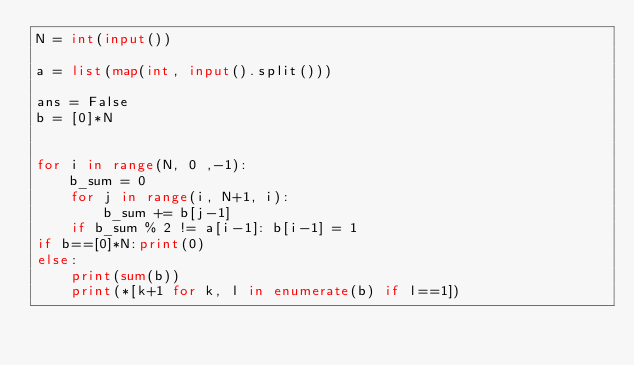<code> <loc_0><loc_0><loc_500><loc_500><_Python_>N = int(input())

a = list(map(int, input().split()))

ans = False
b = [0]*N


for i in range(N, 0 ,-1):
    b_sum = 0
    for j in range(i, N+1, i):
        b_sum += b[j-1]
    if b_sum % 2 != a[i-1]: b[i-1] = 1
if b==[0]*N:print(0)      
else:
    print(sum(b))
    print(*[k+1 for k, l in enumerate(b) if l==1])</code> 